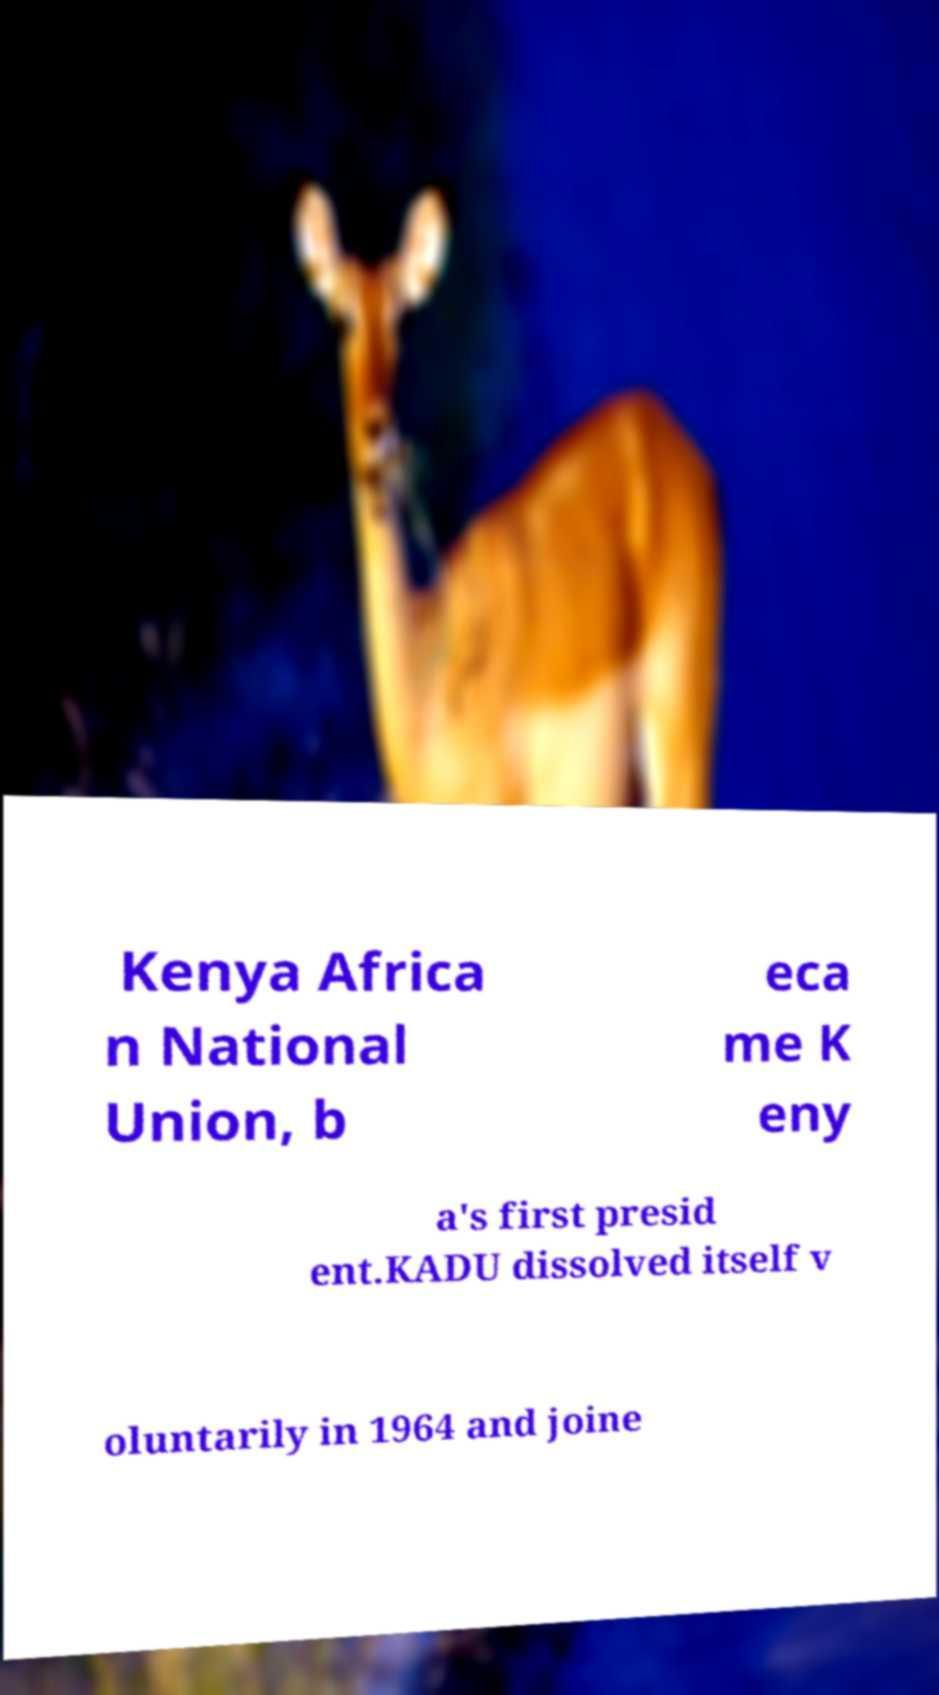I need the written content from this picture converted into text. Can you do that? Kenya Africa n National Union, b eca me K eny a's first presid ent.KADU dissolved itself v oluntarily in 1964 and joine 